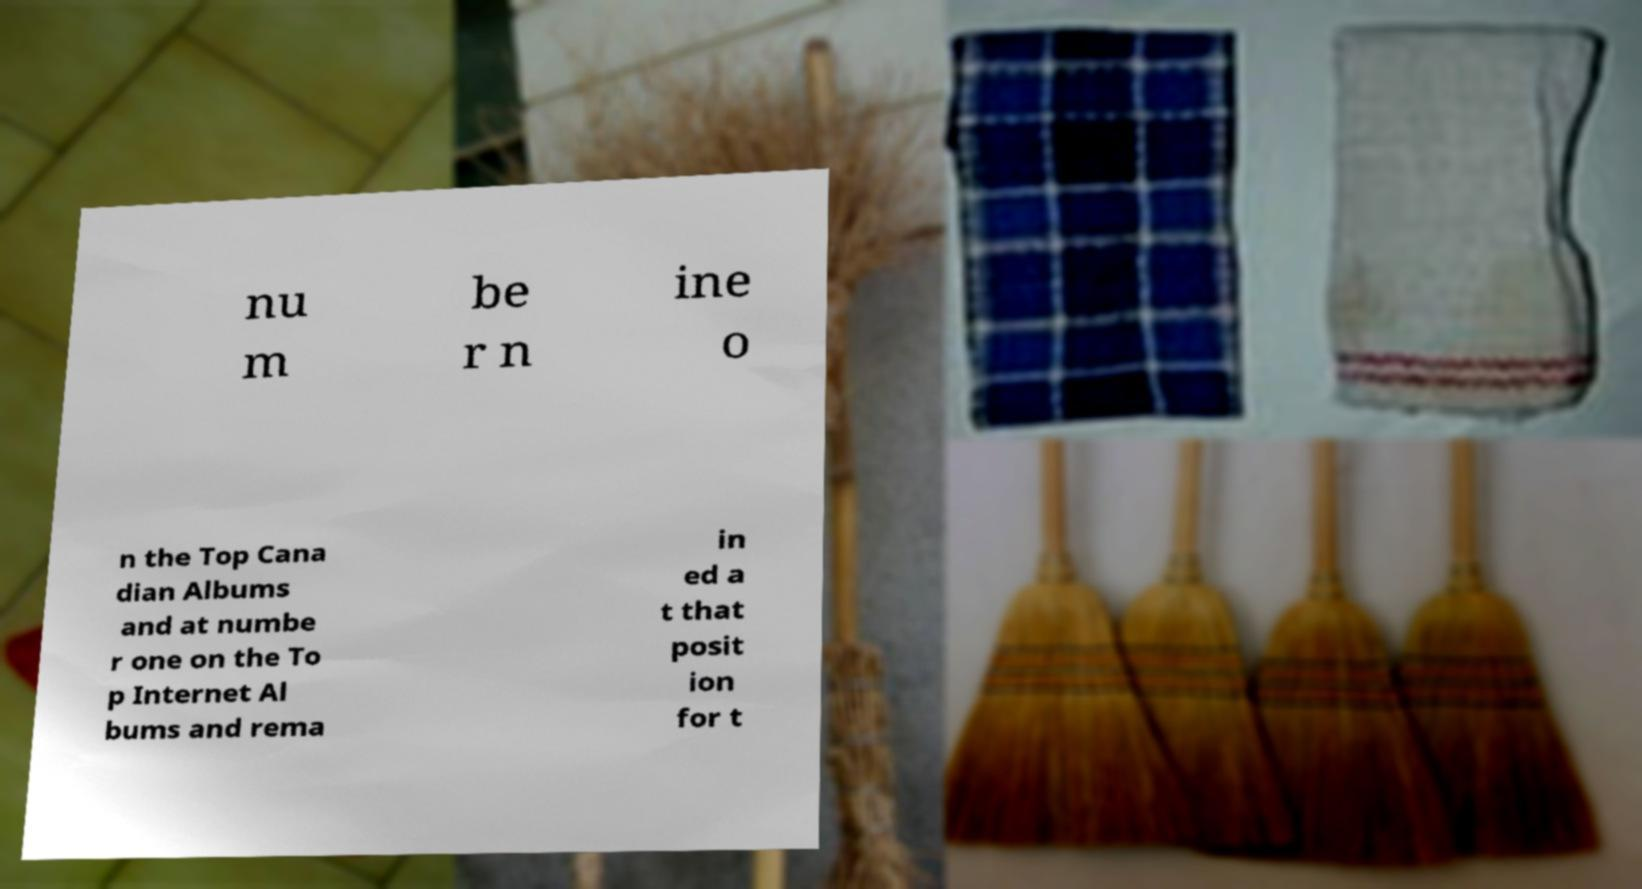Can you accurately transcribe the text from the provided image for me? nu m be r n ine o n the Top Cana dian Albums and at numbe r one on the To p Internet Al bums and rema in ed a t that posit ion for t 